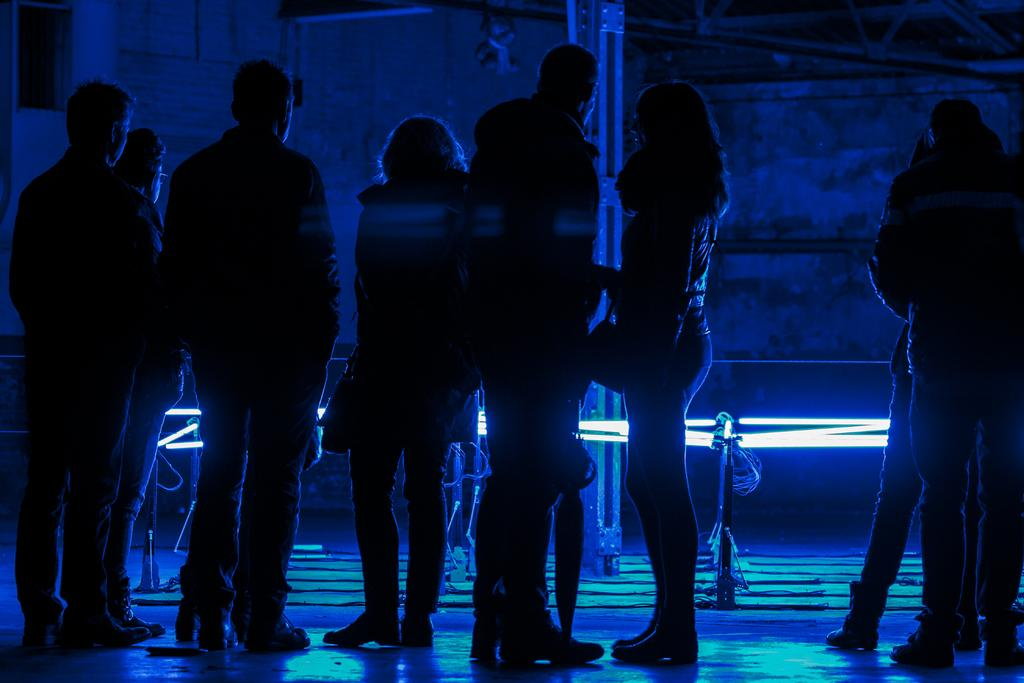How many people are in the image? There is a group of people standing in the image. What can be seen in the background of the image? There is a light in the background of the image. How would you describe the overall lighting in the image? The image appears to be dark overall. How many boats can be seen in the image? There are no boats present in the image. What type of brass object is visible in the image? There is no brass object present in the image. 